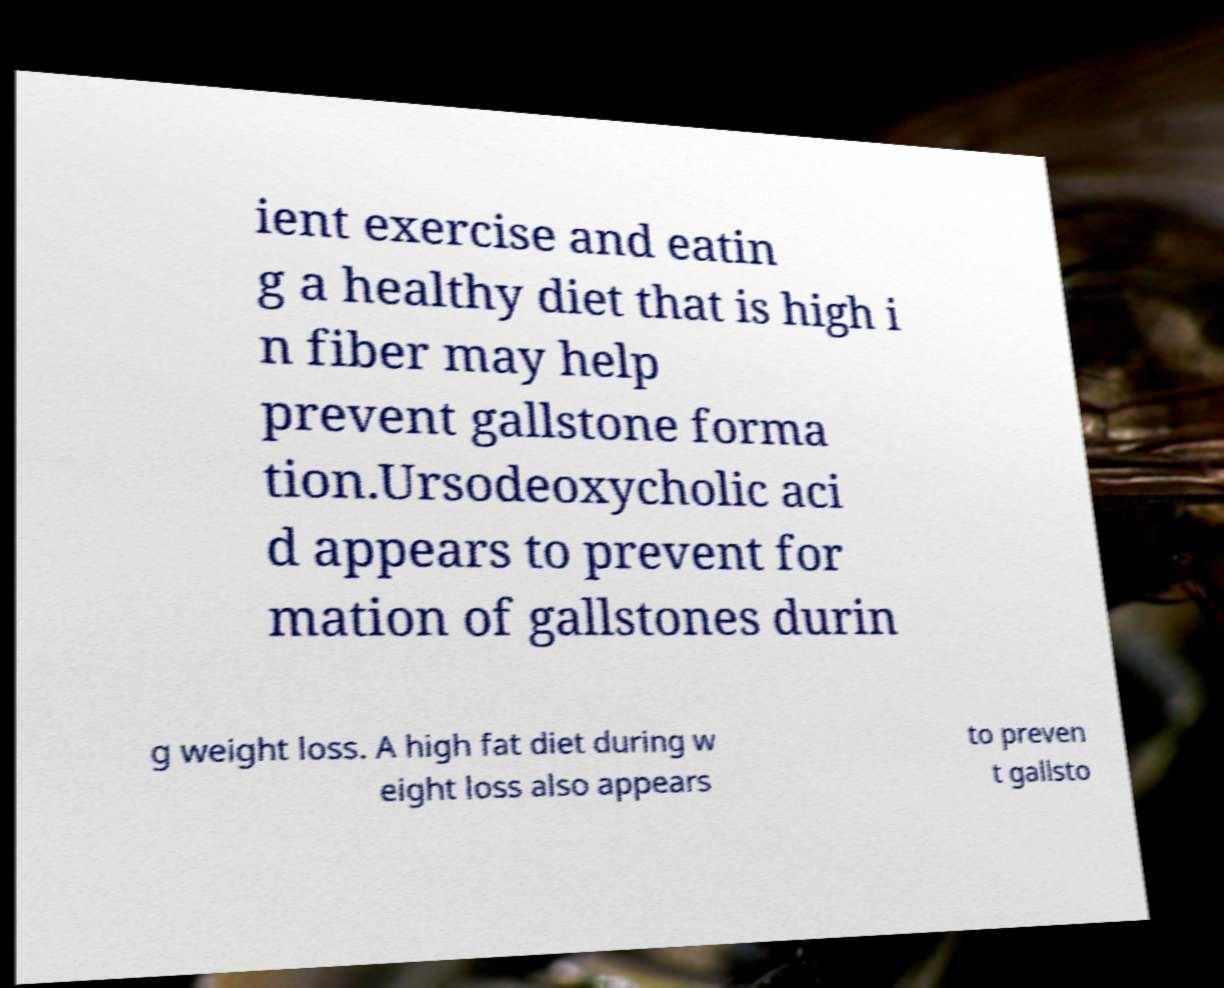What messages or text are displayed in this image? I need them in a readable, typed format. ient exercise and eatin g a healthy diet that is high i n fiber may help prevent gallstone forma tion.Ursodeoxycholic aci d appears to prevent for mation of gallstones durin g weight loss. A high fat diet during w eight loss also appears to preven t gallsto 